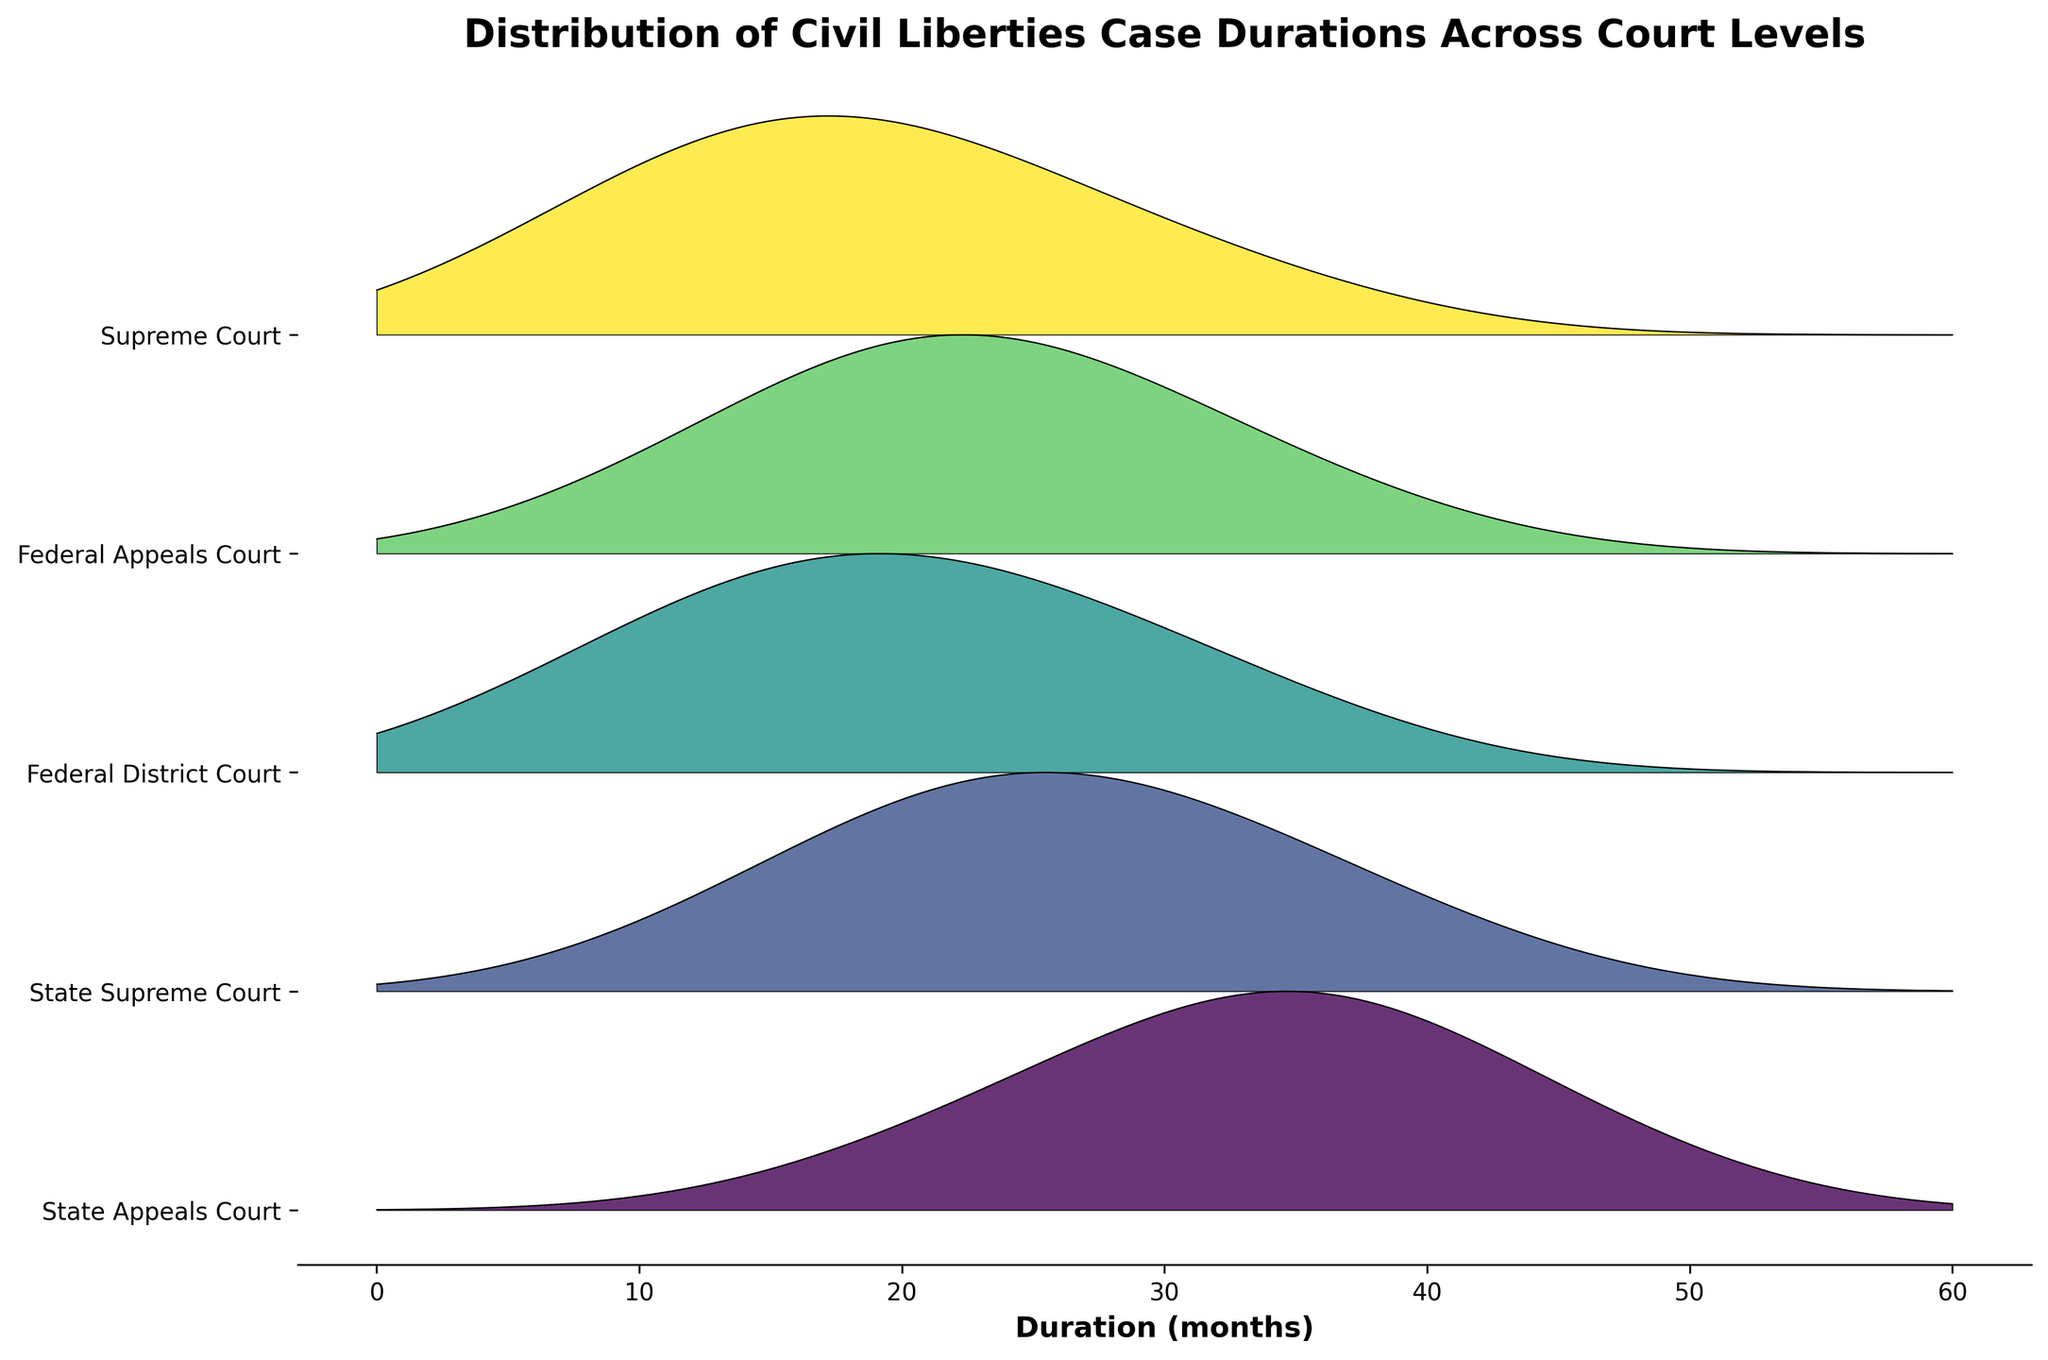What is the title of the plot? The title is located at the top of the plot in bold. It provides an overview of what the plot is about.
Answer: Distribution of Civil Liberties Case Durations Across Court Levels What is the unit of measurement on the x-axis? The x-axis has a label that indicates the unit of measurement.
Answer: Months How many court levels are displayed in the plot? The y-axis shows the different court levels. Counting the unique labels will give the total number of court levels.
Answer: 5 Which court level has the shortest maximum case duration? Observe the highest range of duration months for each court level. The one with the lowest maximum duration is the answer.
Answer: State Appeals Court For which court level is the duration of 36 months most common? Look at the peaks and filled areas in the plot at 36 months for all court levels and identify which one has the highest frequency.
Answer: Supreme Court Which court level shows the most dispersed distribution of case durations? Evaluate the spread and width of the filled areas for each court level. The one with the widest and most spread-out area has the most dispersed distribution.
Answer: State Supreme Court What is the duration range for cases in the Federal District Court? Check the start and end points of the filled area corresponding to the Federal District Court level.
Answer: 6 to 36 months Which court level seems to resolve cases quicker on average? Compare the frequency peaks and central tendencies of the filled areas for all court levels. The court level with the peak shifted to the left resolves cases quicker on average.
Answer: Federal District Court Is there a court level where cases commonly last exactly 30 months? Check for a significant peak in the filled area at the 30 months mark across all court levels.
Answer: State Supreme Court Which court level has the highest frequency for cases lasting exactly 18 months? Look for the court level with the highest peak at the 18 months mark.
Answer: State Appeals Court 